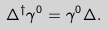Convert formula to latex. <formula><loc_0><loc_0><loc_500><loc_500>\Delta ^ { \dagger } \gamma ^ { 0 } = \gamma ^ { 0 } \Delta .</formula> 